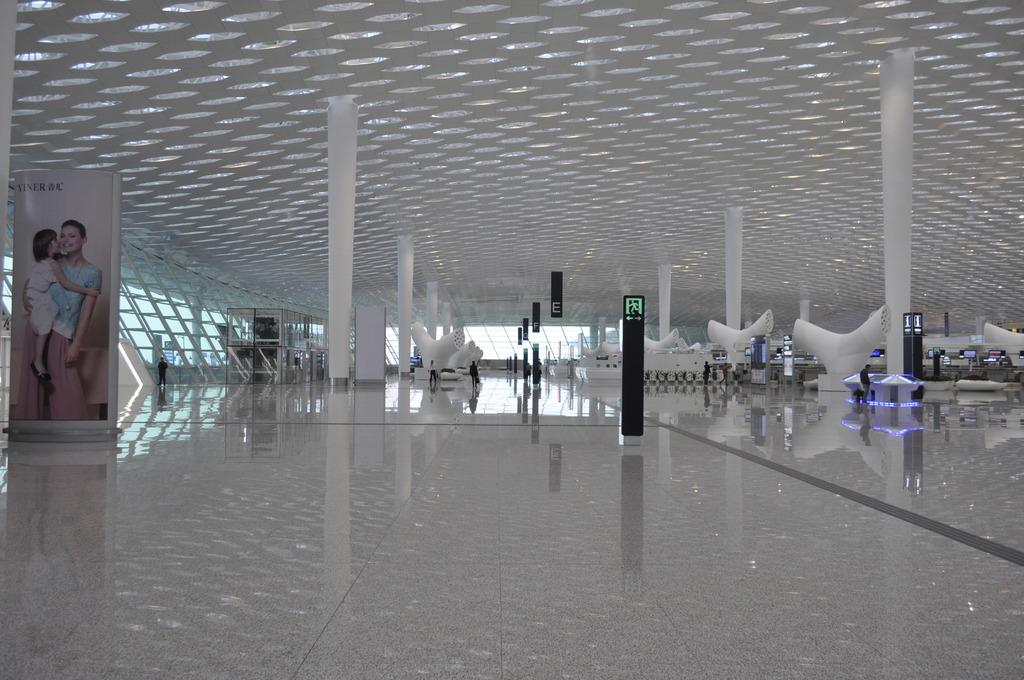What type of flooring is visible in the image? There are floorboards in the image. What architectural features can be seen in the image? There are pillars in the image. What type of advertisements are present in the image? There are hoardings in the image. Can you describe the people in the image? There are people in the image. What other objects are present in the image? There are objects in the image. What is visible in the background of the image? The background of the image includes a ceiling and lights. Can you tell me where the tiger is hiding in the image? There is no tiger present in the image. What type of key is used to unlock the door in the image? There is no door or key present in the image. 